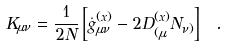Convert formula to latex. <formula><loc_0><loc_0><loc_500><loc_500>K _ { \mu \nu } = \frac { 1 } { 2 N } \left [ \dot { g } ^ { ( x ) } _ { \mu \nu } - 2 D ^ { ( x ) } _ { ( \mu } N _ { \nu ) } \right ] \ .</formula> 